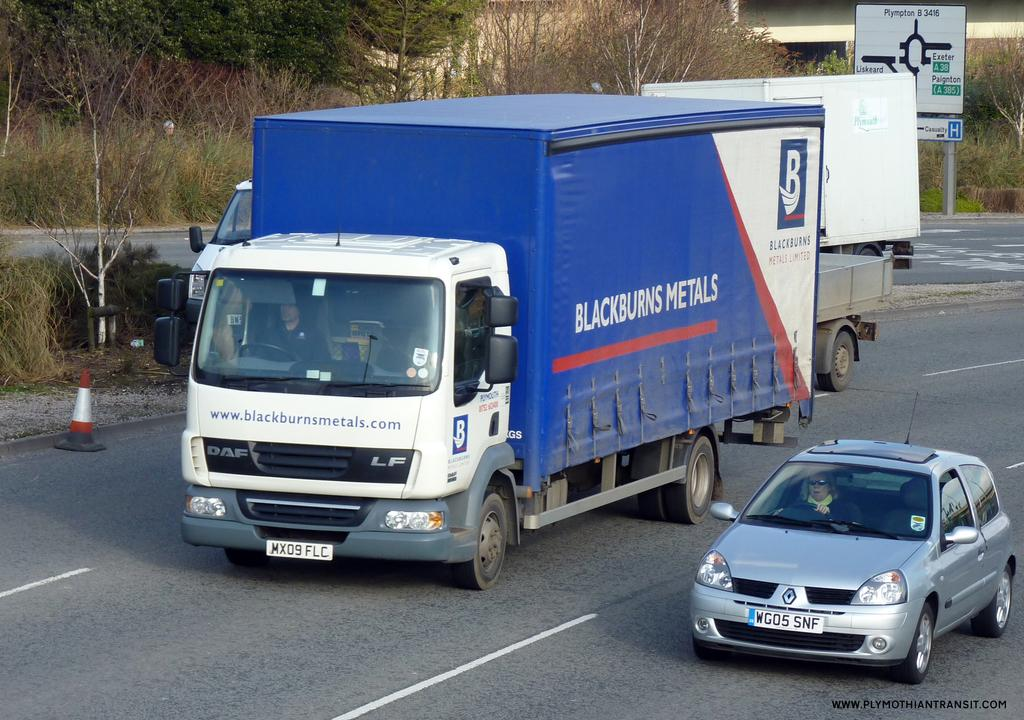What types of objects are present in the image? There are vehicles in the image. Can you describe the color of one of the vehicles? One vehicle is white and blue in color. What is located in the background of the image? There is a board attached to a pole in the background. What can be seen behind the board? Trees are visible in the background. What is the color of the trees? The trees are green in color. Where is the cushion placed in the image? There is no cushion present in the image. 